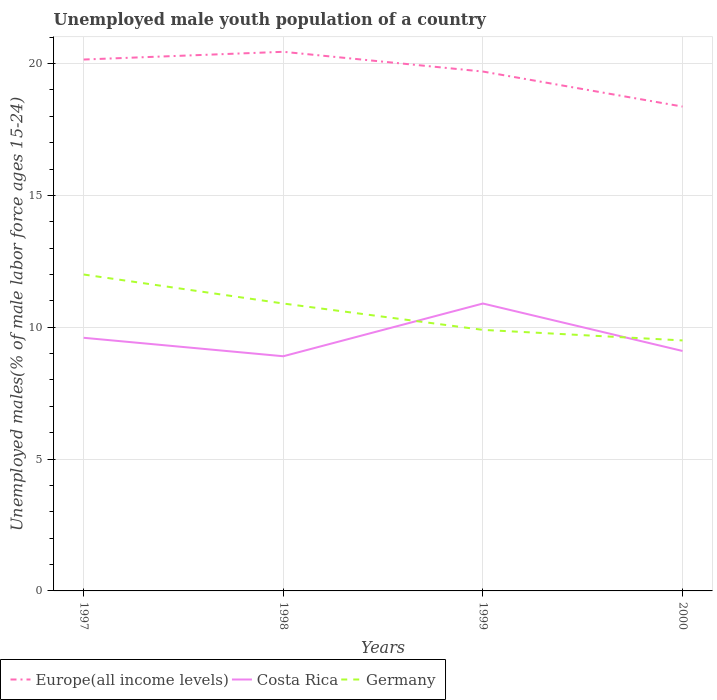How many different coloured lines are there?
Make the answer very short. 3. Does the line corresponding to Europe(all income levels) intersect with the line corresponding to Germany?
Your answer should be very brief. No. Is the number of lines equal to the number of legend labels?
Offer a very short reply. Yes. Across all years, what is the maximum percentage of unemployed male youth population in Costa Rica?
Offer a terse response. 8.9. In which year was the percentage of unemployed male youth population in Europe(all income levels) maximum?
Ensure brevity in your answer.  2000. What is the total percentage of unemployed male youth population in Europe(all income levels) in the graph?
Your answer should be very brief. 0.46. What is the difference between the highest and the second highest percentage of unemployed male youth population in Costa Rica?
Keep it short and to the point. 2. Is the percentage of unemployed male youth population in Costa Rica strictly greater than the percentage of unemployed male youth population in Germany over the years?
Give a very brief answer. No. How many lines are there?
Your answer should be very brief. 3. How many years are there in the graph?
Offer a very short reply. 4. What is the difference between two consecutive major ticks on the Y-axis?
Keep it short and to the point. 5. Are the values on the major ticks of Y-axis written in scientific E-notation?
Your response must be concise. No. Does the graph contain grids?
Provide a short and direct response. Yes. Where does the legend appear in the graph?
Keep it short and to the point. Bottom left. What is the title of the graph?
Offer a terse response. Unemployed male youth population of a country. What is the label or title of the X-axis?
Offer a terse response. Years. What is the label or title of the Y-axis?
Offer a terse response. Unemployed males(% of male labor force ages 15-24). What is the Unemployed males(% of male labor force ages 15-24) of Europe(all income levels) in 1997?
Offer a terse response. 20.15. What is the Unemployed males(% of male labor force ages 15-24) of Costa Rica in 1997?
Provide a short and direct response. 9.6. What is the Unemployed males(% of male labor force ages 15-24) in Germany in 1997?
Provide a succinct answer. 12. What is the Unemployed males(% of male labor force ages 15-24) in Europe(all income levels) in 1998?
Ensure brevity in your answer.  20.45. What is the Unemployed males(% of male labor force ages 15-24) in Costa Rica in 1998?
Make the answer very short. 8.9. What is the Unemployed males(% of male labor force ages 15-24) of Germany in 1998?
Provide a succinct answer. 10.9. What is the Unemployed males(% of male labor force ages 15-24) of Europe(all income levels) in 1999?
Your answer should be very brief. 19.7. What is the Unemployed males(% of male labor force ages 15-24) in Costa Rica in 1999?
Keep it short and to the point. 10.9. What is the Unemployed males(% of male labor force ages 15-24) of Germany in 1999?
Give a very brief answer. 9.9. What is the Unemployed males(% of male labor force ages 15-24) of Europe(all income levels) in 2000?
Ensure brevity in your answer.  18.37. What is the Unemployed males(% of male labor force ages 15-24) in Costa Rica in 2000?
Offer a very short reply. 9.1. What is the Unemployed males(% of male labor force ages 15-24) of Germany in 2000?
Ensure brevity in your answer.  9.5. Across all years, what is the maximum Unemployed males(% of male labor force ages 15-24) of Europe(all income levels)?
Provide a short and direct response. 20.45. Across all years, what is the maximum Unemployed males(% of male labor force ages 15-24) in Costa Rica?
Your response must be concise. 10.9. Across all years, what is the maximum Unemployed males(% of male labor force ages 15-24) in Germany?
Provide a short and direct response. 12. Across all years, what is the minimum Unemployed males(% of male labor force ages 15-24) of Europe(all income levels)?
Keep it short and to the point. 18.37. Across all years, what is the minimum Unemployed males(% of male labor force ages 15-24) of Costa Rica?
Your answer should be very brief. 8.9. Across all years, what is the minimum Unemployed males(% of male labor force ages 15-24) in Germany?
Offer a very short reply. 9.5. What is the total Unemployed males(% of male labor force ages 15-24) in Europe(all income levels) in the graph?
Make the answer very short. 78.67. What is the total Unemployed males(% of male labor force ages 15-24) of Costa Rica in the graph?
Make the answer very short. 38.5. What is the total Unemployed males(% of male labor force ages 15-24) in Germany in the graph?
Give a very brief answer. 42.3. What is the difference between the Unemployed males(% of male labor force ages 15-24) of Europe(all income levels) in 1997 and that in 1998?
Your answer should be compact. -0.29. What is the difference between the Unemployed males(% of male labor force ages 15-24) in Costa Rica in 1997 and that in 1998?
Your response must be concise. 0.7. What is the difference between the Unemployed males(% of male labor force ages 15-24) in Europe(all income levels) in 1997 and that in 1999?
Your answer should be compact. 0.46. What is the difference between the Unemployed males(% of male labor force ages 15-24) of Germany in 1997 and that in 1999?
Keep it short and to the point. 2.1. What is the difference between the Unemployed males(% of male labor force ages 15-24) in Europe(all income levels) in 1997 and that in 2000?
Your response must be concise. 1.78. What is the difference between the Unemployed males(% of male labor force ages 15-24) in Costa Rica in 1997 and that in 2000?
Offer a very short reply. 0.5. What is the difference between the Unemployed males(% of male labor force ages 15-24) of Europe(all income levels) in 1998 and that in 1999?
Offer a terse response. 0.75. What is the difference between the Unemployed males(% of male labor force ages 15-24) of Costa Rica in 1998 and that in 1999?
Your answer should be compact. -2. What is the difference between the Unemployed males(% of male labor force ages 15-24) in Europe(all income levels) in 1998 and that in 2000?
Provide a short and direct response. 2.08. What is the difference between the Unemployed males(% of male labor force ages 15-24) of Germany in 1998 and that in 2000?
Your answer should be very brief. 1.4. What is the difference between the Unemployed males(% of male labor force ages 15-24) in Europe(all income levels) in 1999 and that in 2000?
Ensure brevity in your answer.  1.33. What is the difference between the Unemployed males(% of male labor force ages 15-24) in Germany in 1999 and that in 2000?
Your answer should be very brief. 0.4. What is the difference between the Unemployed males(% of male labor force ages 15-24) in Europe(all income levels) in 1997 and the Unemployed males(% of male labor force ages 15-24) in Costa Rica in 1998?
Provide a succinct answer. 11.25. What is the difference between the Unemployed males(% of male labor force ages 15-24) in Europe(all income levels) in 1997 and the Unemployed males(% of male labor force ages 15-24) in Germany in 1998?
Ensure brevity in your answer.  9.25. What is the difference between the Unemployed males(% of male labor force ages 15-24) of Europe(all income levels) in 1997 and the Unemployed males(% of male labor force ages 15-24) of Costa Rica in 1999?
Give a very brief answer. 9.25. What is the difference between the Unemployed males(% of male labor force ages 15-24) in Europe(all income levels) in 1997 and the Unemployed males(% of male labor force ages 15-24) in Germany in 1999?
Make the answer very short. 10.25. What is the difference between the Unemployed males(% of male labor force ages 15-24) of Europe(all income levels) in 1997 and the Unemployed males(% of male labor force ages 15-24) of Costa Rica in 2000?
Give a very brief answer. 11.05. What is the difference between the Unemployed males(% of male labor force ages 15-24) of Europe(all income levels) in 1997 and the Unemployed males(% of male labor force ages 15-24) of Germany in 2000?
Your response must be concise. 10.65. What is the difference between the Unemployed males(% of male labor force ages 15-24) in Costa Rica in 1997 and the Unemployed males(% of male labor force ages 15-24) in Germany in 2000?
Your response must be concise. 0.1. What is the difference between the Unemployed males(% of male labor force ages 15-24) of Europe(all income levels) in 1998 and the Unemployed males(% of male labor force ages 15-24) of Costa Rica in 1999?
Ensure brevity in your answer.  9.55. What is the difference between the Unemployed males(% of male labor force ages 15-24) in Europe(all income levels) in 1998 and the Unemployed males(% of male labor force ages 15-24) in Germany in 1999?
Provide a succinct answer. 10.55. What is the difference between the Unemployed males(% of male labor force ages 15-24) of Costa Rica in 1998 and the Unemployed males(% of male labor force ages 15-24) of Germany in 1999?
Make the answer very short. -1. What is the difference between the Unemployed males(% of male labor force ages 15-24) of Europe(all income levels) in 1998 and the Unemployed males(% of male labor force ages 15-24) of Costa Rica in 2000?
Your response must be concise. 11.35. What is the difference between the Unemployed males(% of male labor force ages 15-24) in Europe(all income levels) in 1998 and the Unemployed males(% of male labor force ages 15-24) in Germany in 2000?
Your answer should be very brief. 10.95. What is the difference between the Unemployed males(% of male labor force ages 15-24) of Europe(all income levels) in 1999 and the Unemployed males(% of male labor force ages 15-24) of Costa Rica in 2000?
Offer a very short reply. 10.6. What is the difference between the Unemployed males(% of male labor force ages 15-24) in Europe(all income levels) in 1999 and the Unemployed males(% of male labor force ages 15-24) in Germany in 2000?
Your answer should be compact. 10.2. What is the average Unemployed males(% of male labor force ages 15-24) of Europe(all income levels) per year?
Your answer should be very brief. 19.67. What is the average Unemployed males(% of male labor force ages 15-24) in Costa Rica per year?
Your response must be concise. 9.62. What is the average Unemployed males(% of male labor force ages 15-24) of Germany per year?
Provide a short and direct response. 10.57. In the year 1997, what is the difference between the Unemployed males(% of male labor force ages 15-24) in Europe(all income levels) and Unemployed males(% of male labor force ages 15-24) in Costa Rica?
Your answer should be compact. 10.55. In the year 1997, what is the difference between the Unemployed males(% of male labor force ages 15-24) of Europe(all income levels) and Unemployed males(% of male labor force ages 15-24) of Germany?
Your response must be concise. 8.15. In the year 1998, what is the difference between the Unemployed males(% of male labor force ages 15-24) in Europe(all income levels) and Unemployed males(% of male labor force ages 15-24) in Costa Rica?
Your response must be concise. 11.55. In the year 1998, what is the difference between the Unemployed males(% of male labor force ages 15-24) in Europe(all income levels) and Unemployed males(% of male labor force ages 15-24) in Germany?
Offer a terse response. 9.55. In the year 1998, what is the difference between the Unemployed males(% of male labor force ages 15-24) of Costa Rica and Unemployed males(% of male labor force ages 15-24) of Germany?
Ensure brevity in your answer.  -2. In the year 1999, what is the difference between the Unemployed males(% of male labor force ages 15-24) of Europe(all income levels) and Unemployed males(% of male labor force ages 15-24) of Costa Rica?
Keep it short and to the point. 8.8. In the year 1999, what is the difference between the Unemployed males(% of male labor force ages 15-24) in Europe(all income levels) and Unemployed males(% of male labor force ages 15-24) in Germany?
Keep it short and to the point. 9.8. In the year 1999, what is the difference between the Unemployed males(% of male labor force ages 15-24) in Costa Rica and Unemployed males(% of male labor force ages 15-24) in Germany?
Make the answer very short. 1. In the year 2000, what is the difference between the Unemployed males(% of male labor force ages 15-24) in Europe(all income levels) and Unemployed males(% of male labor force ages 15-24) in Costa Rica?
Your response must be concise. 9.27. In the year 2000, what is the difference between the Unemployed males(% of male labor force ages 15-24) in Europe(all income levels) and Unemployed males(% of male labor force ages 15-24) in Germany?
Give a very brief answer. 8.87. In the year 2000, what is the difference between the Unemployed males(% of male labor force ages 15-24) in Costa Rica and Unemployed males(% of male labor force ages 15-24) in Germany?
Give a very brief answer. -0.4. What is the ratio of the Unemployed males(% of male labor force ages 15-24) of Europe(all income levels) in 1997 to that in 1998?
Keep it short and to the point. 0.99. What is the ratio of the Unemployed males(% of male labor force ages 15-24) in Costa Rica in 1997 to that in 1998?
Make the answer very short. 1.08. What is the ratio of the Unemployed males(% of male labor force ages 15-24) of Germany in 1997 to that in 1998?
Offer a very short reply. 1.1. What is the ratio of the Unemployed males(% of male labor force ages 15-24) in Europe(all income levels) in 1997 to that in 1999?
Provide a short and direct response. 1.02. What is the ratio of the Unemployed males(% of male labor force ages 15-24) in Costa Rica in 1997 to that in 1999?
Give a very brief answer. 0.88. What is the ratio of the Unemployed males(% of male labor force ages 15-24) in Germany in 1997 to that in 1999?
Your answer should be very brief. 1.21. What is the ratio of the Unemployed males(% of male labor force ages 15-24) of Europe(all income levels) in 1997 to that in 2000?
Your answer should be very brief. 1.1. What is the ratio of the Unemployed males(% of male labor force ages 15-24) in Costa Rica in 1997 to that in 2000?
Make the answer very short. 1.05. What is the ratio of the Unemployed males(% of male labor force ages 15-24) of Germany in 1997 to that in 2000?
Give a very brief answer. 1.26. What is the ratio of the Unemployed males(% of male labor force ages 15-24) of Europe(all income levels) in 1998 to that in 1999?
Provide a short and direct response. 1.04. What is the ratio of the Unemployed males(% of male labor force ages 15-24) of Costa Rica in 1998 to that in 1999?
Give a very brief answer. 0.82. What is the ratio of the Unemployed males(% of male labor force ages 15-24) of Germany in 1998 to that in 1999?
Ensure brevity in your answer.  1.1. What is the ratio of the Unemployed males(% of male labor force ages 15-24) in Europe(all income levels) in 1998 to that in 2000?
Your response must be concise. 1.11. What is the ratio of the Unemployed males(% of male labor force ages 15-24) of Germany in 1998 to that in 2000?
Provide a succinct answer. 1.15. What is the ratio of the Unemployed males(% of male labor force ages 15-24) in Europe(all income levels) in 1999 to that in 2000?
Your answer should be very brief. 1.07. What is the ratio of the Unemployed males(% of male labor force ages 15-24) in Costa Rica in 1999 to that in 2000?
Offer a very short reply. 1.2. What is the ratio of the Unemployed males(% of male labor force ages 15-24) in Germany in 1999 to that in 2000?
Offer a very short reply. 1.04. What is the difference between the highest and the second highest Unemployed males(% of male labor force ages 15-24) of Europe(all income levels)?
Keep it short and to the point. 0.29. What is the difference between the highest and the second highest Unemployed males(% of male labor force ages 15-24) of Costa Rica?
Your response must be concise. 1.3. What is the difference between the highest and the lowest Unemployed males(% of male labor force ages 15-24) in Europe(all income levels)?
Provide a short and direct response. 2.08. 